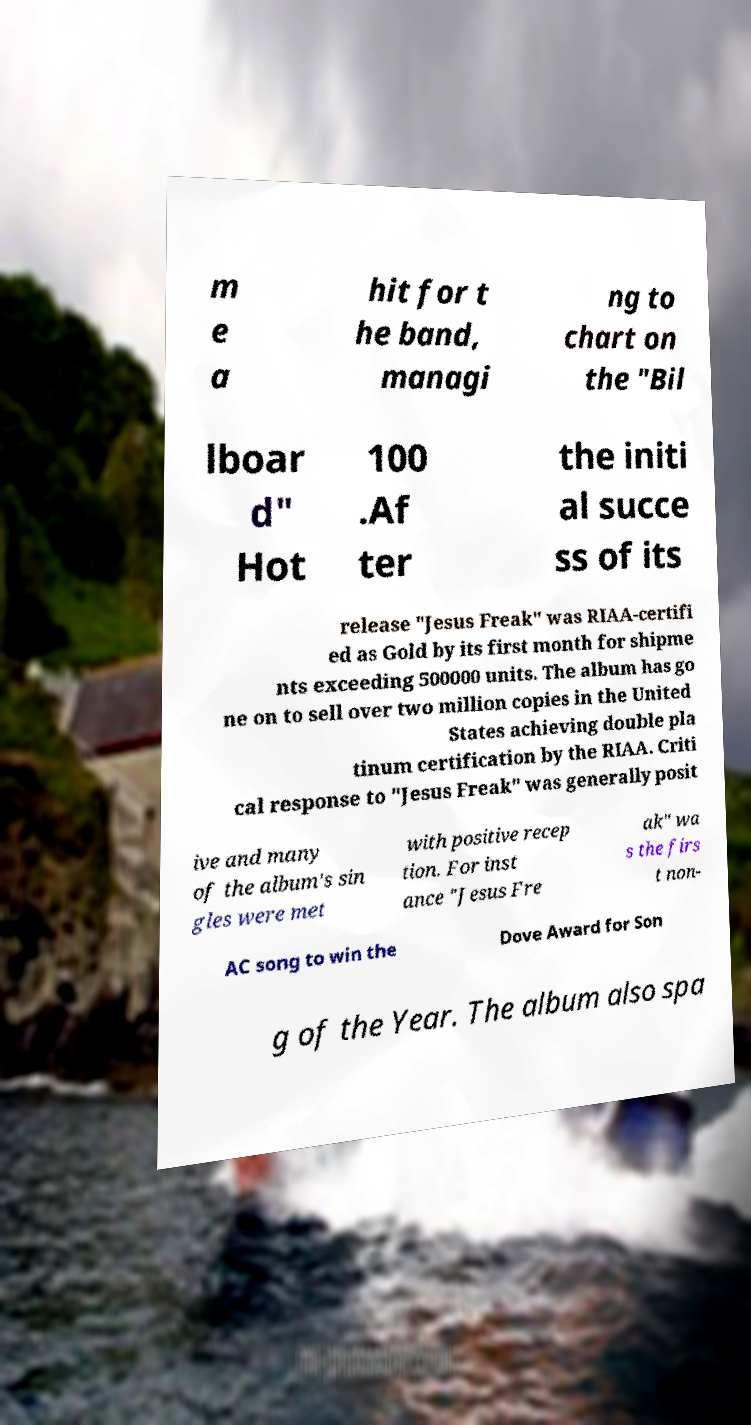Please read and relay the text visible in this image. What does it say? m e a hit for t he band, managi ng to chart on the "Bil lboar d" Hot 100 .Af ter the initi al succe ss of its release "Jesus Freak" was RIAA-certifi ed as Gold by its first month for shipme nts exceeding 500000 units. The album has go ne on to sell over two million copies in the United States achieving double pla tinum certification by the RIAA. Criti cal response to "Jesus Freak" was generally posit ive and many of the album's sin gles were met with positive recep tion. For inst ance "Jesus Fre ak" wa s the firs t non- AC song to win the Dove Award for Son g of the Year. The album also spa 